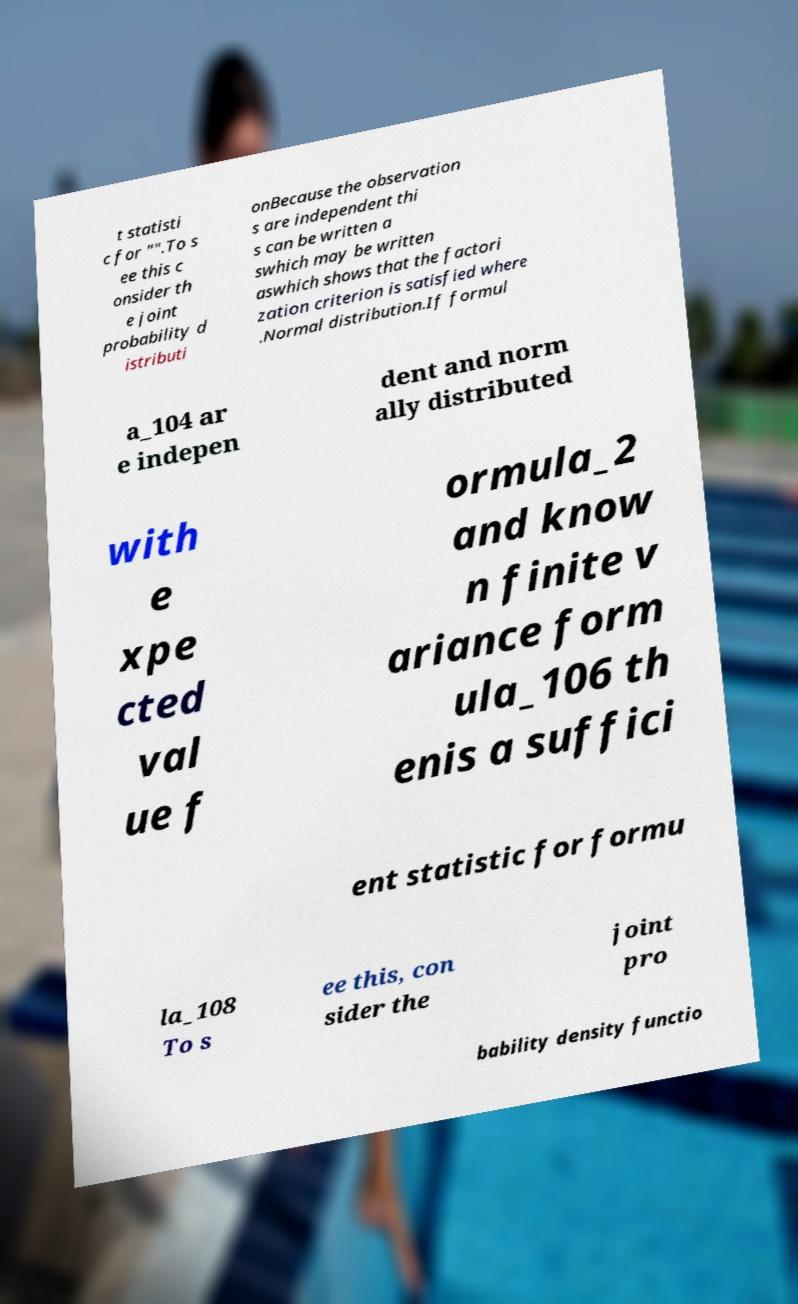I need the written content from this picture converted into text. Can you do that? t statisti c for "".To s ee this c onsider th e joint probability d istributi onBecause the observation s are independent thi s can be written a swhich may be written aswhich shows that the factori zation criterion is satisfied where .Normal distribution.If formul a_104 ar e indepen dent and norm ally distributed with e xpe cted val ue f ormula_2 and know n finite v ariance form ula_106 th enis a suffici ent statistic for formu la_108 To s ee this, con sider the joint pro bability density functio 